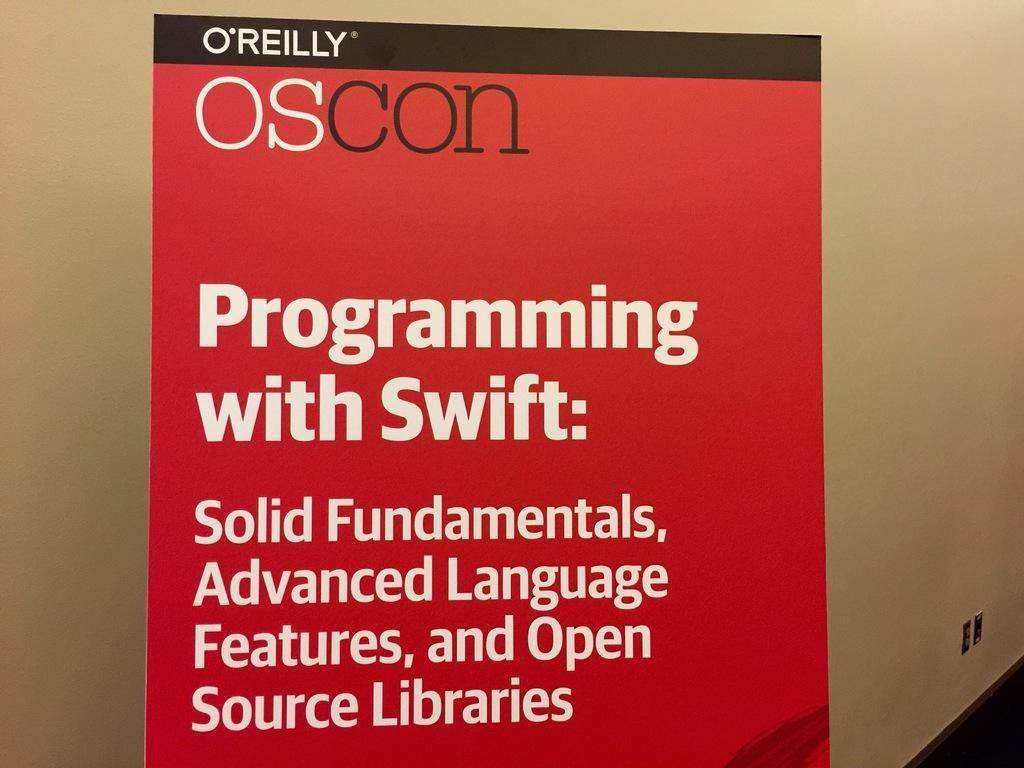<image>
Give a short and clear explanation of the subsequent image. Programming with Swift: Solid Fundamentals, Advanced Language Features, and Open Source Libraries, reads this graphic. 